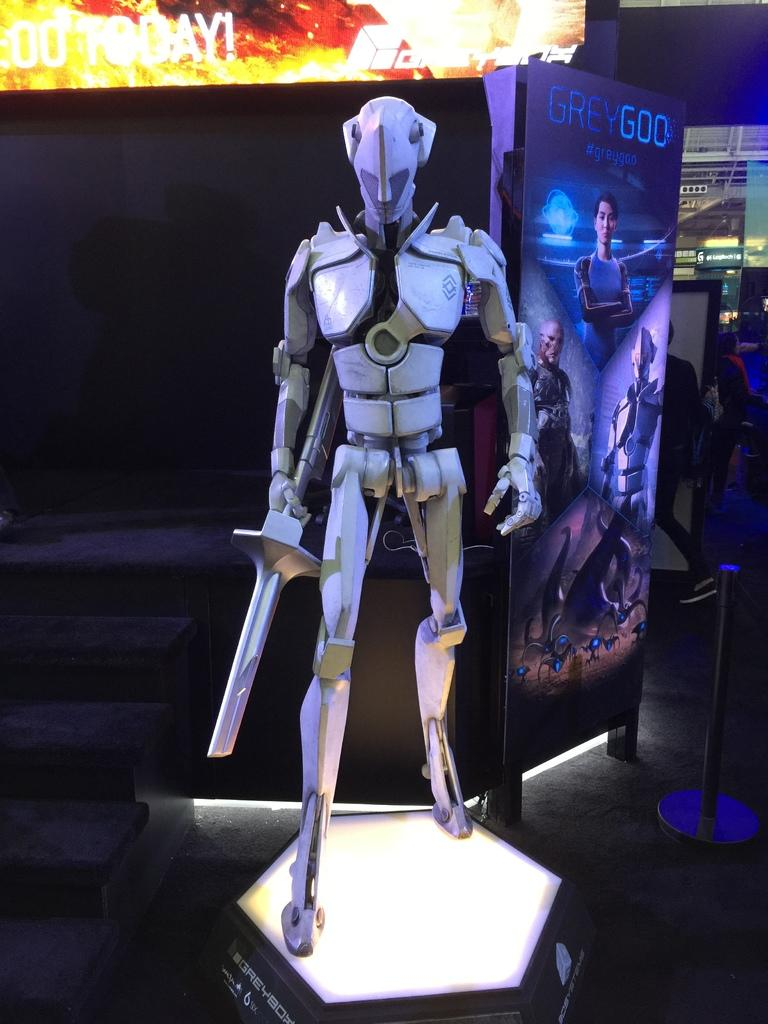What is the main subject in the center of the image? There is a robot in the center of the image. What else can be seen in the image besides the robot? There is a poster at the top side of the image. What type of cork is being used by the robot to point at the minister in the image? There is no cork, minister, or pointing action present in the image. 